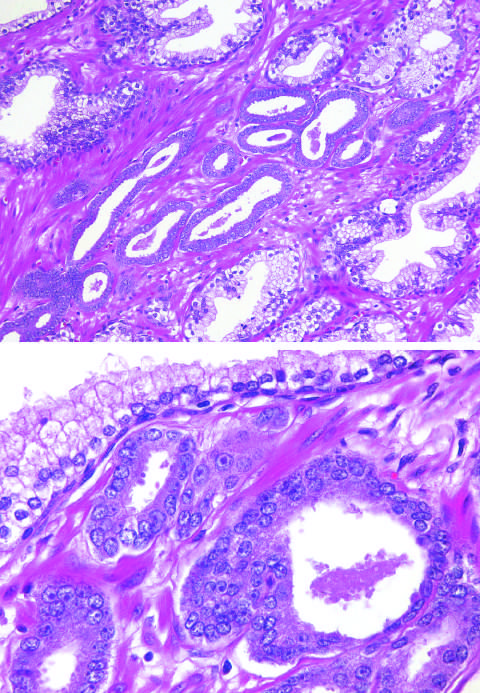re t_h17 cells crowded in between larger benign glands?
Answer the question using a single word or phrase. No 